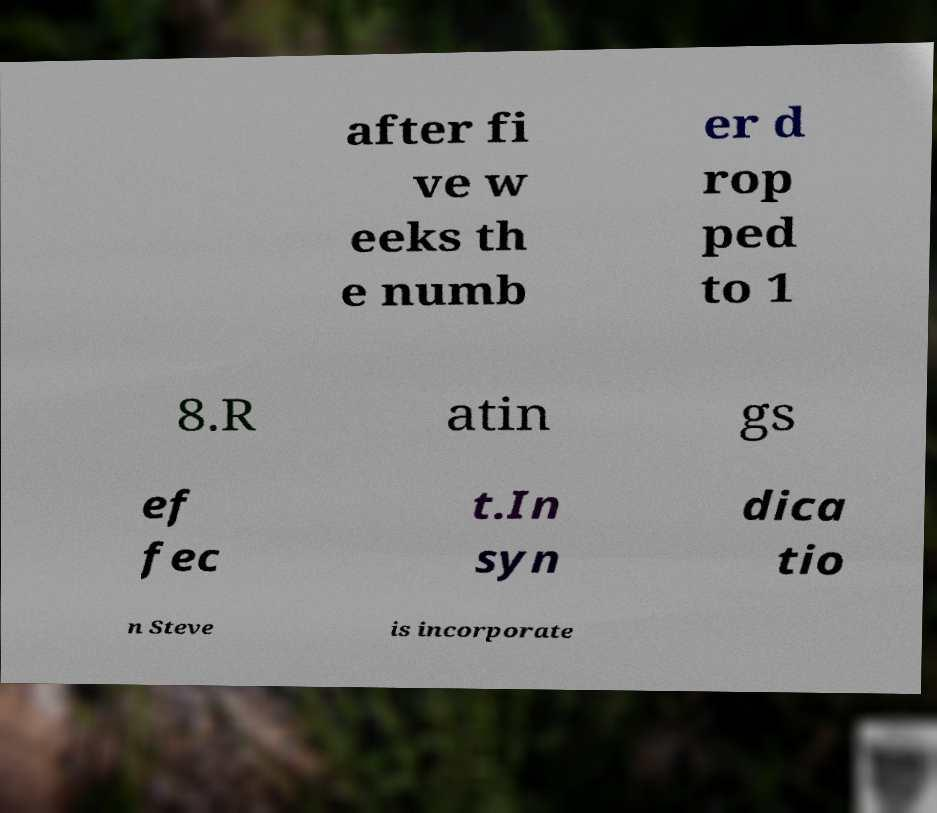There's text embedded in this image that I need extracted. Can you transcribe it verbatim? after fi ve w eeks th e numb er d rop ped to 1 8.R atin gs ef fec t.In syn dica tio n Steve is incorporate 